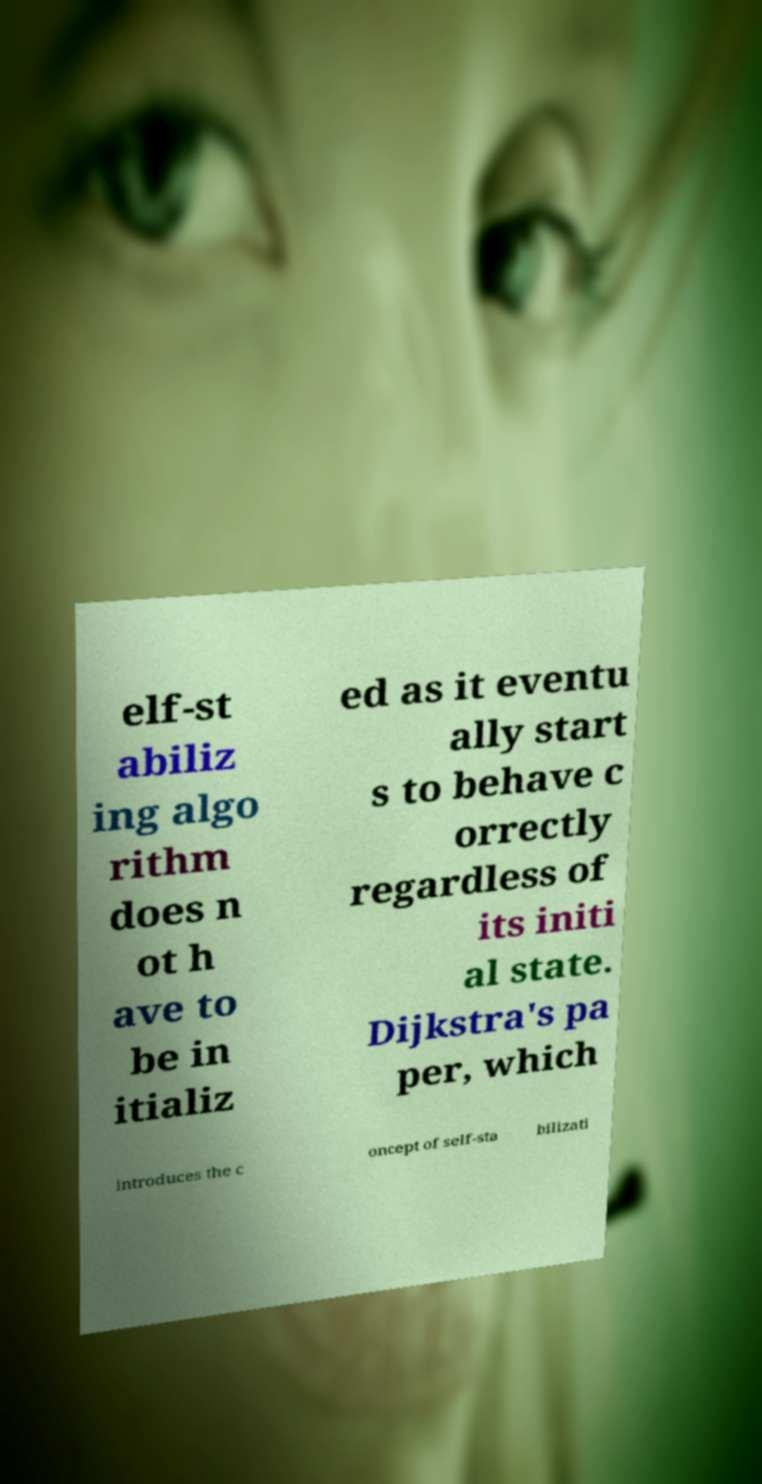Can you read and provide the text displayed in the image?This photo seems to have some interesting text. Can you extract and type it out for me? elf-st abiliz ing algo rithm does n ot h ave to be in itializ ed as it eventu ally start s to behave c orrectly regardless of its initi al state. Dijkstra's pa per, which introduces the c oncept of self-sta bilizati 